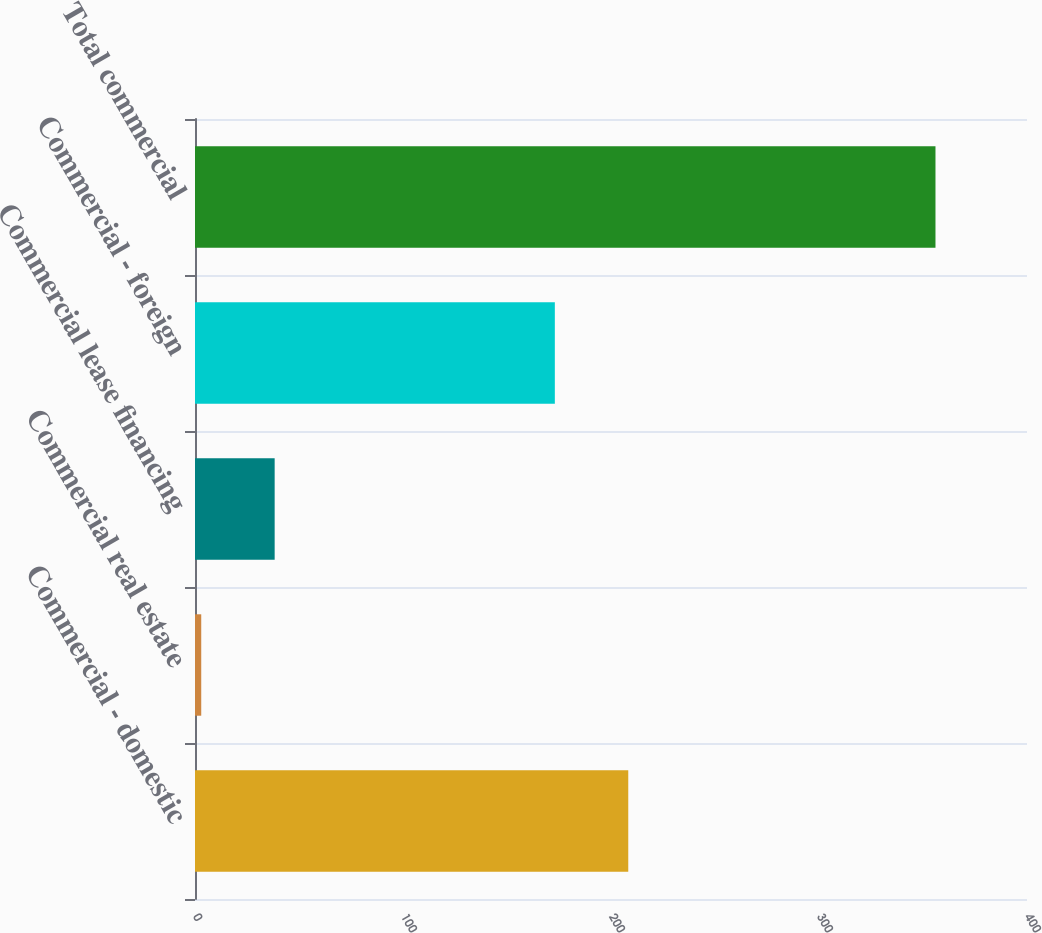Convert chart. <chart><loc_0><loc_0><loc_500><loc_500><bar_chart><fcel>Commercial - domestic<fcel>Commercial real estate<fcel>Commercial lease financing<fcel>Commercial - foreign<fcel>Total commercial<nl><fcel>208.3<fcel>3<fcel>38.3<fcel>173<fcel>356<nl></chart> 